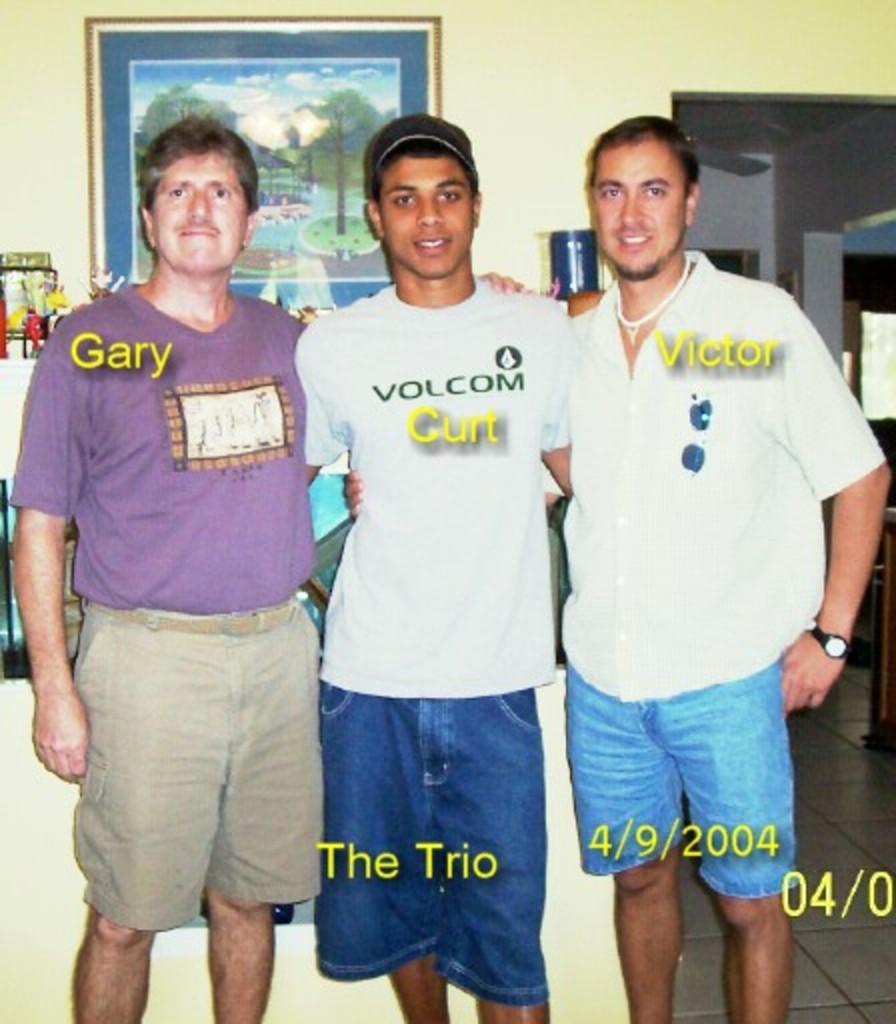Please provide a concise description of this image. In this image I can see three persons on persons I can see text and at the top I can see the wall , on the wall I can see there is a photo frame. 